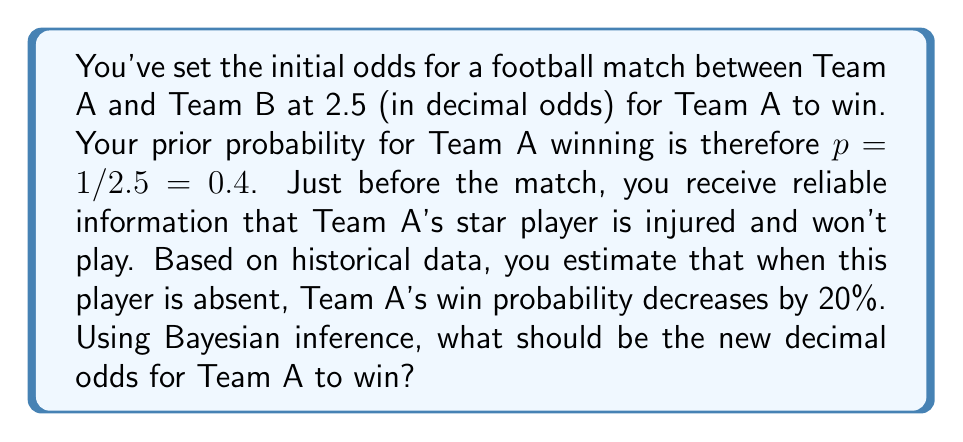Can you answer this question? Let's approach this step-by-step using Bayesian inference:

1) Our prior probability of Team A winning: $P(A) = 0.4$

2) We need to calculate the likelihood of the new information (star player absent) given that Team A wins. We're told that Team A's win probability decreases by 20% when this player is absent. This means:

   $P(E|A) = 0.8$, where E is the event "star player is absent"

3) We also need $P(E)$, the probability of the evidence regardless of the outcome:
   
   $P(E) = P(E|A)P(A) + P(E|\neg A)P(\neg A)$
   $= 0.8 * 0.4 + 1 * 0.6 = 0.32 + 0.6 = 0.92$

4) Now we can apply Bayes' theorem:

   $P(A|E) = \frac{P(E|A)P(A)}{P(E)}$

5) Plugging in our values:

   $P(A|E) = \frac{0.8 * 0.4}{0.92} \approx 0.3478$

6) To convert this probability to decimal odds, we use the formula:

   $\text{Decimal Odds} = \frac{1}{\text{Probability}}$

7) Therefore, the new decimal odds are:

   $\text{New Odds} = \frac{1}{0.3478} \approx 2.875$
Answer: 2.88 (rounded to 2 decimal places) 